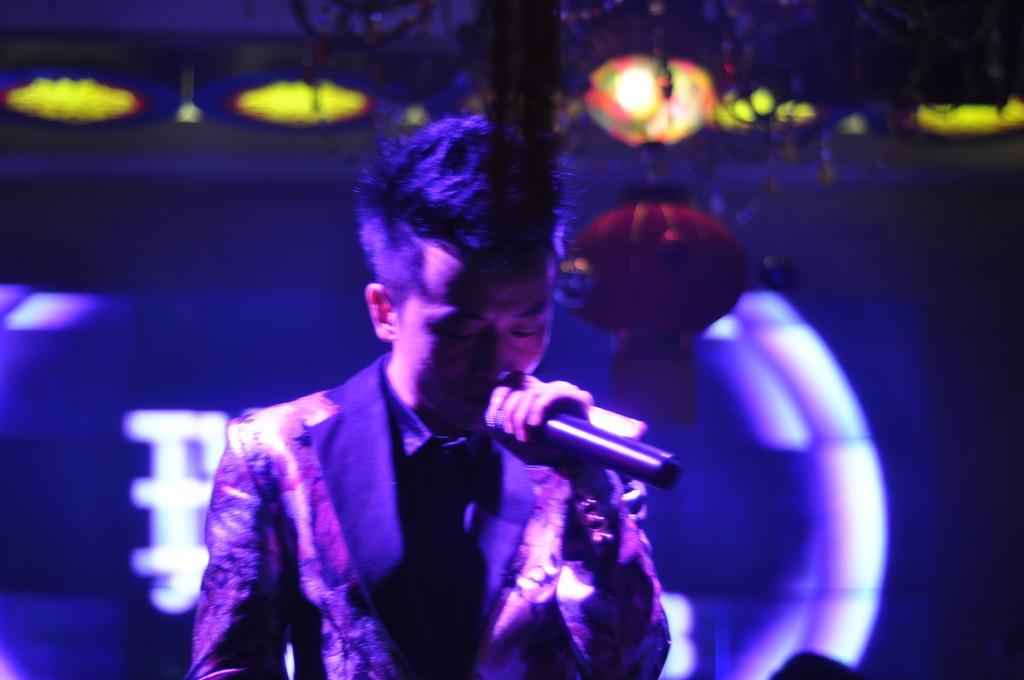Can you describe this image briefly? In this image there is a person singing by holding the mic. At the top there are lights. In the background it looks like some design. 